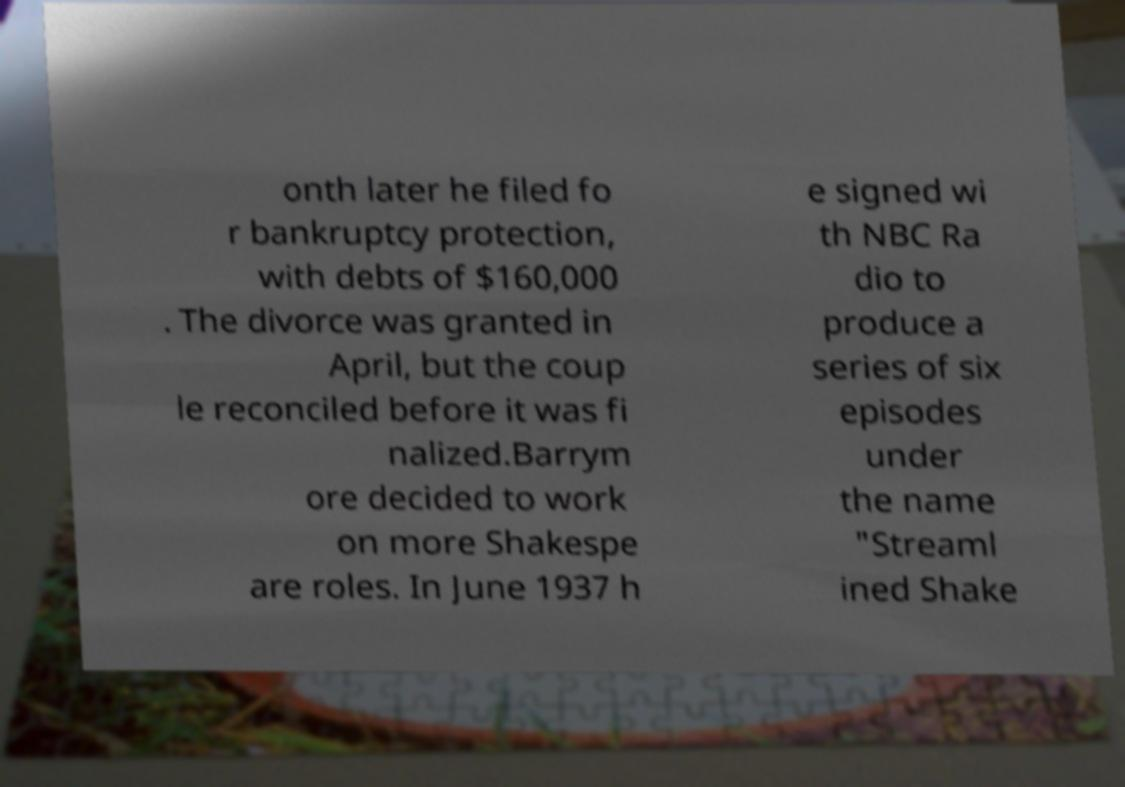There's text embedded in this image that I need extracted. Can you transcribe it verbatim? onth later he filed fo r bankruptcy protection, with debts of $160,000 . The divorce was granted in April, but the coup le reconciled before it was fi nalized.Barrym ore decided to work on more Shakespe are roles. In June 1937 h e signed wi th NBC Ra dio to produce a series of six episodes under the name "Streaml ined Shake 